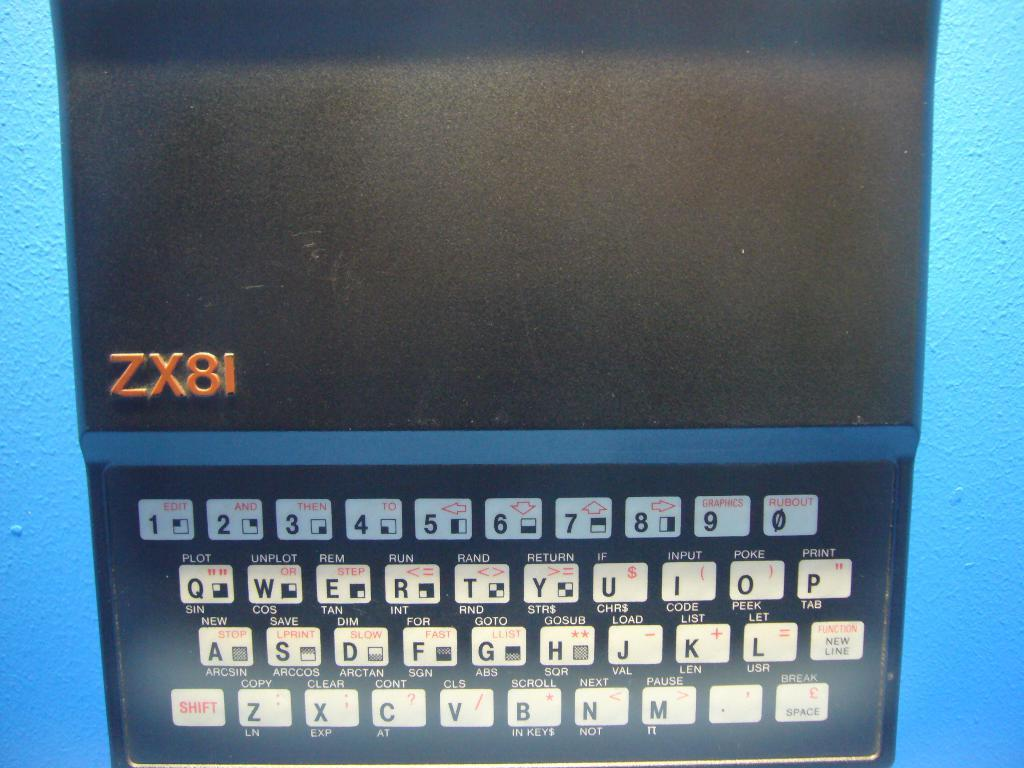<image>
Provide a brief description of the given image. A blue device with ZX81 on the screen. 